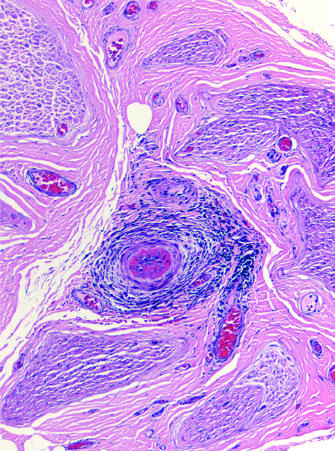what does the perineurial connective tissue contain?
Answer the question using a single word or phrase. An inflammatory infiltrate around small blood vessels 